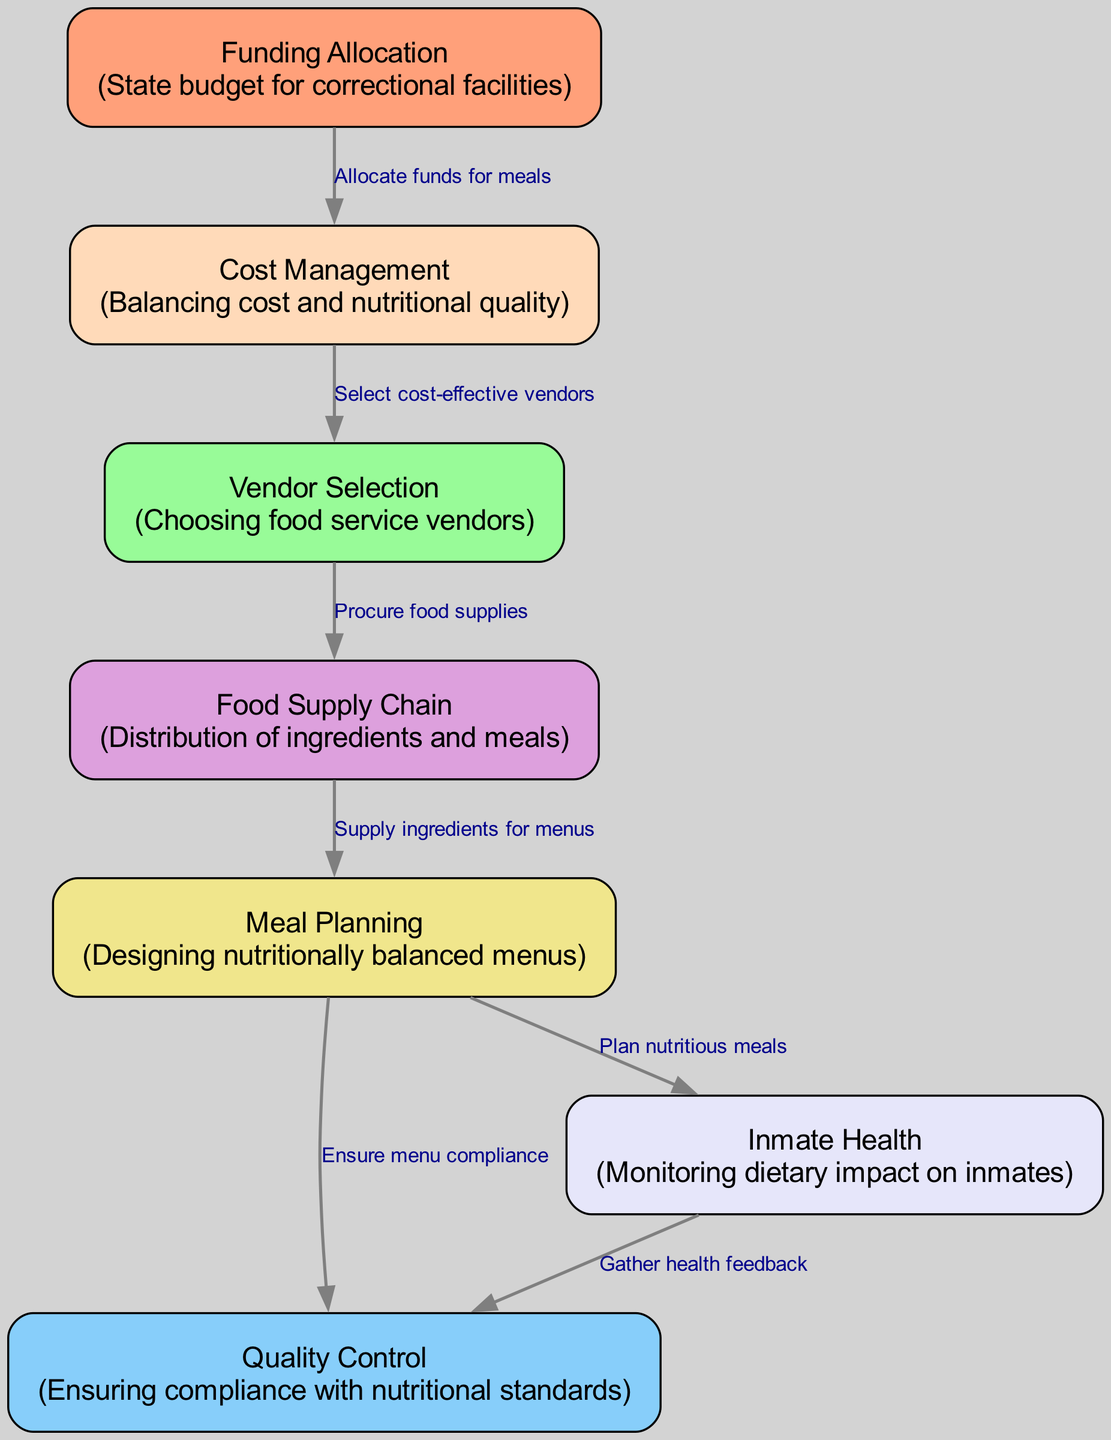What is the total number of nodes in the diagram? The diagram includes a list of nodes that are represented by identifiers. Counting each unique node in the provided data results in a total of seven nodes.
Answer: 7 Which node deals with budget allocation for meals? The "Funding Allocation" node is responsible for allocating funds for meals, as indicated by the directed edge showing its relationship with the "Cost Management" node.
Answer: Funding Allocation What is one of the main responsibilities of the "Quality Control" node? The "Quality Control" node ensures compliance with nutritional standards, as described in its description accompanying the label.
Answer: Compliance with nutritional standards How does the "Meal Planning" node connect to inmate health management? The "Meal Planning" node is linked to the "Inmate Health" node by providing nutritious meals, demonstrated by the directed edge between them.
Answer: By planning nutritious meals What do the arrows in the diagram represent? The arrows in the diagram indicate the flow of processes or relationships between the nodes, showing how one element influences another in the food chain.
Answer: Flow of processes Which node is involved in selecting food service vendors? The "Vendor Selection" node is responsible for selecting food service vendors, as indicated by its placement and direct connection from the "Cost Management" node.
Answer: Vendor Selection What type of information do the edges represent in the food chain diagram? The edges represent the relationships or actions taken between the nodes, where each edge is labeled to explain the nature of the connection.
Answer: Relationships or actions How is the process of monitoring inmate health described in the diagram? The process is described as part of the connections between the "Inmate Health" node and the "Quality Control" node, where health feedback is gathered to ensure compliance.
Answer: By gathering health feedback 